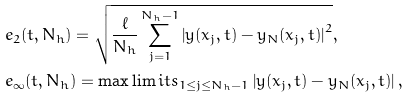Convert formula to latex. <formula><loc_0><loc_0><loc_500><loc_500>& e _ { 2 } ( t , N _ { h } ) = \sqrt { \frac { \ell } { N _ { h } } \sum ^ { N _ { h } - 1 } _ { j = 1 } \left | y ( x _ { j } , t ) - y _ { N } ( x _ { j } , t ) \right | ^ { 2 } } , \\ & e _ { \infty } ( t , N _ { h } ) = \max \lim i t s _ { 1 \leq j \leq N _ { h } - 1 } \left | y ( x _ { j } , t ) - y _ { N } ( x _ { j } , t ) \right | ,</formula> 